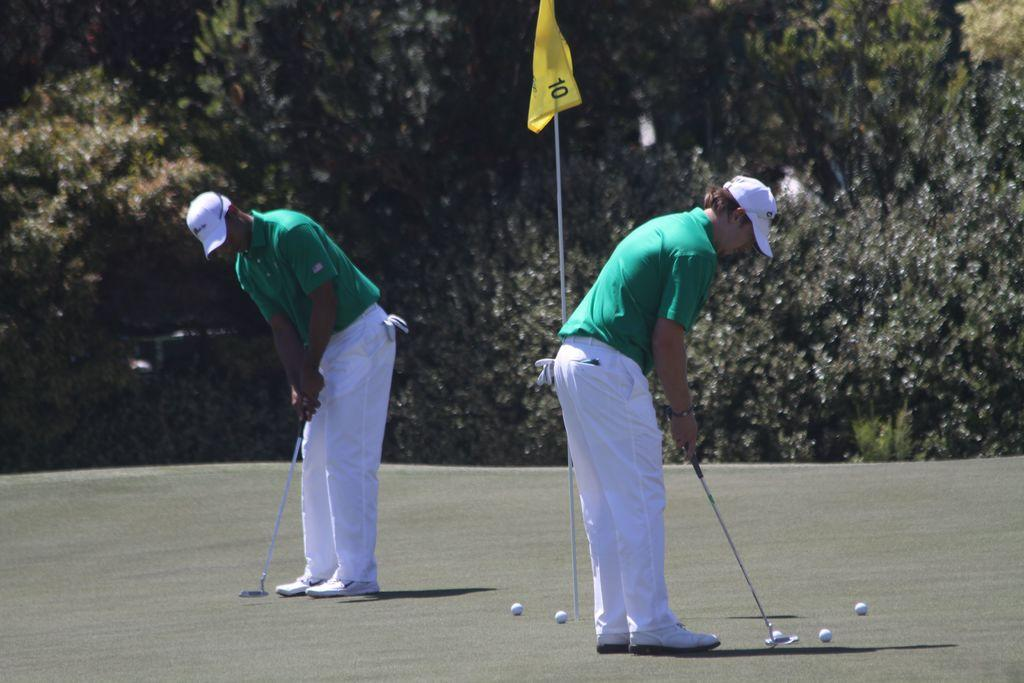How many people are in the image? There are two persons in the image. What are the persons wearing on their heads? Both persons are wearing caps. What are the persons holding in their hands? The persons are holding golf sticks. What objects are on the ground near the persons? There are golf balls on the ground. What can be seen in the background of the image? There are trees in the background of the image. What is the flag attached to in the image? The flag is attached to a pole. Are the children in the image sleeping? There are no children present in the image, and the persons in the image are not sleeping. 